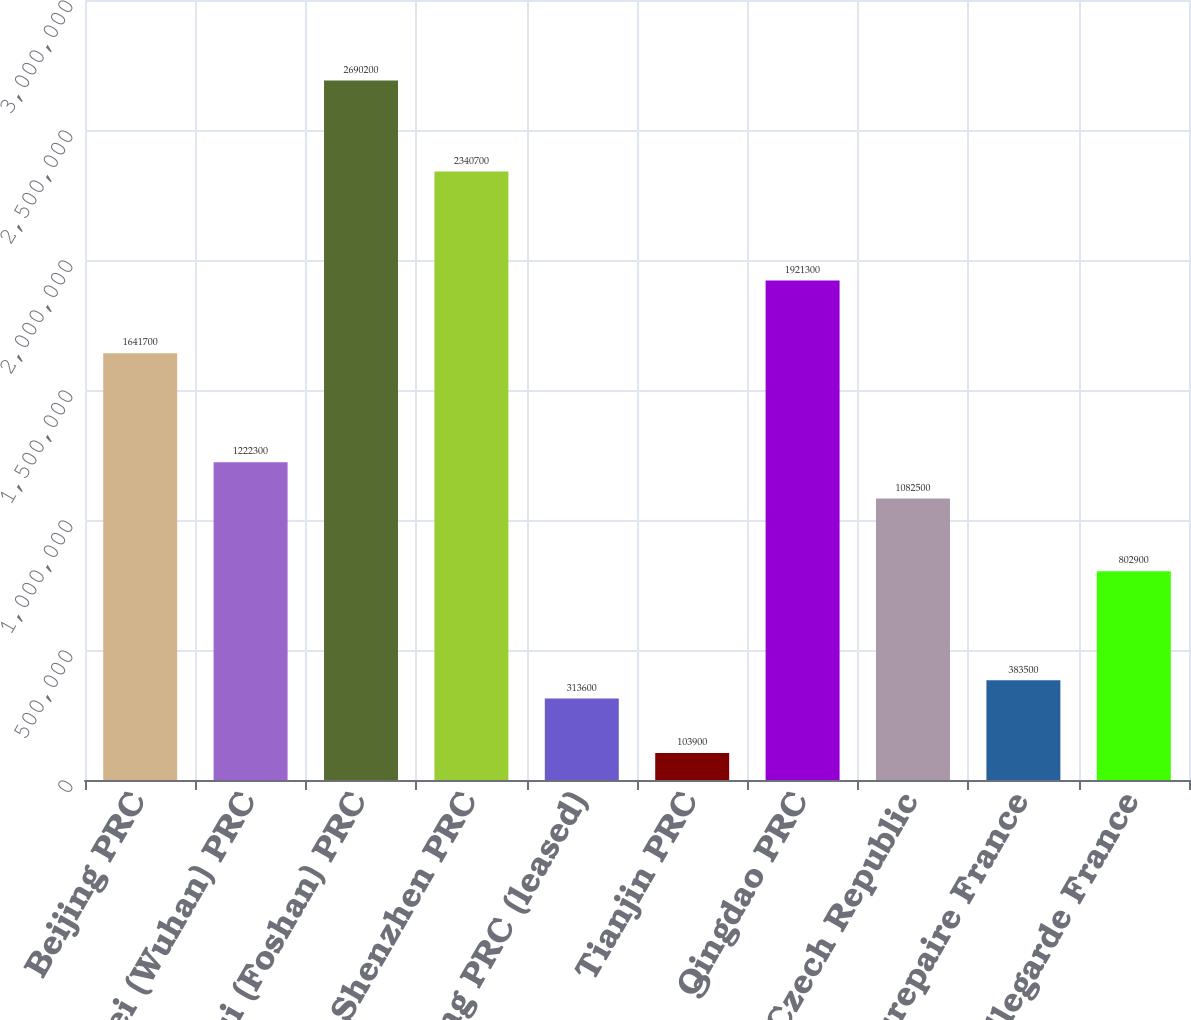Convert chart to OTSL. <chart><loc_0><loc_0><loc_500><loc_500><bar_chart><fcel>Beijing PRC<fcel>Hubei (Wuhan) PRC<fcel>Sanshui (Foshan) PRC<fcel>Shenzhen PRC<fcel>Taicang PRC (leased)<fcel>Tianjin PRC<fcel>Qingdao PRC<fcel>Velim Czech Republic<fcel>Beaurepaire France<fcel>Bellegarde France<nl><fcel>1.6417e+06<fcel>1.2223e+06<fcel>2.6902e+06<fcel>2.3407e+06<fcel>313600<fcel>103900<fcel>1.9213e+06<fcel>1.0825e+06<fcel>383500<fcel>802900<nl></chart> 